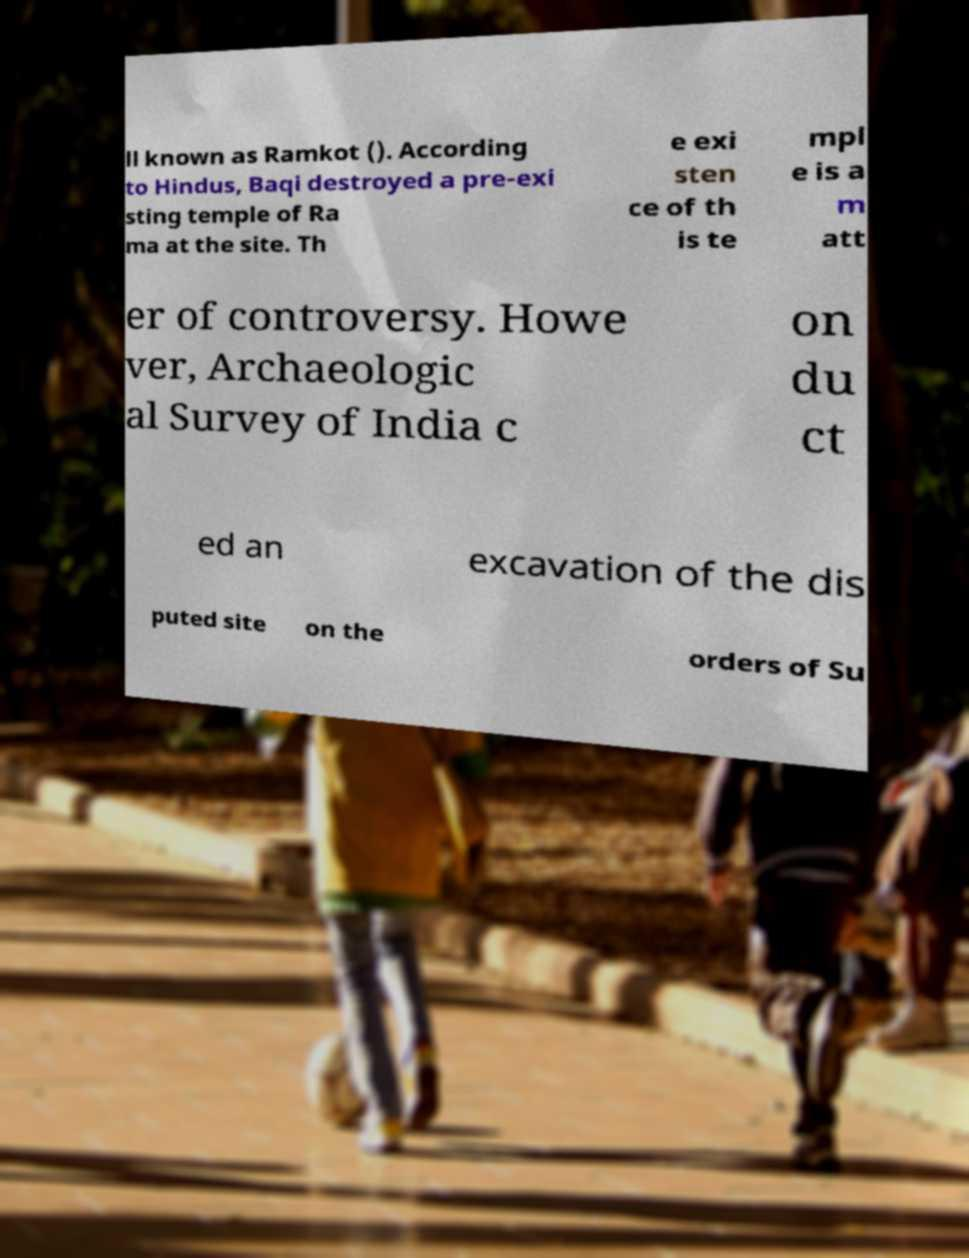What messages or text are displayed in this image? I need them in a readable, typed format. ll known as Ramkot (). According to Hindus, Baqi destroyed a pre-exi sting temple of Ra ma at the site. Th e exi sten ce of th is te mpl e is a m att er of controversy. Howe ver, Archaeologic al Survey of India c on du ct ed an excavation of the dis puted site on the orders of Su 